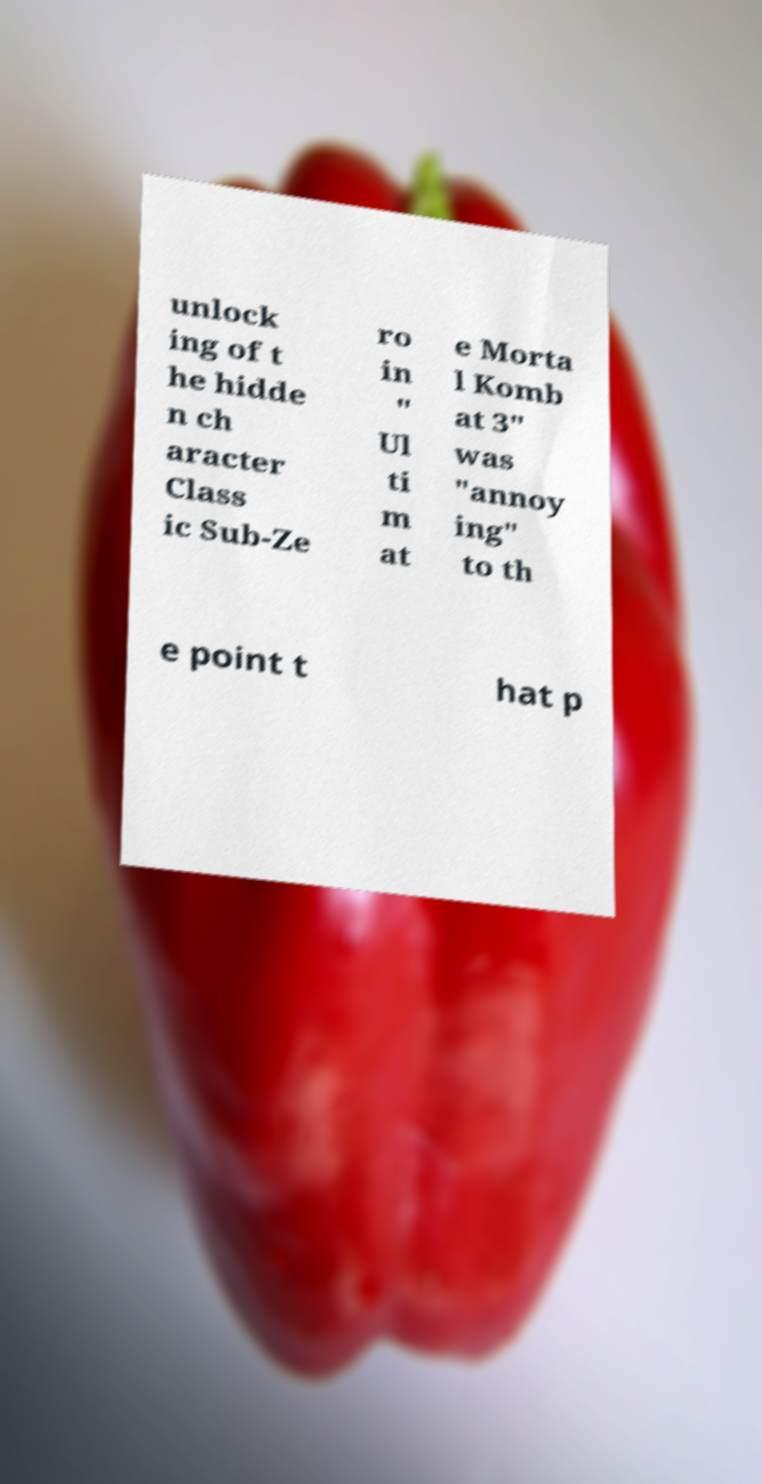Can you read and provide the text displayed in the image?This photo seems to have some interesting text. Can you extract and type it out for me? unlock ing of t he hidde n ch aracter Class ic Sub-Ze ro in " Ul ti m at e Morta l Komb at 3" was "annoy ing" to th e point t hat p 